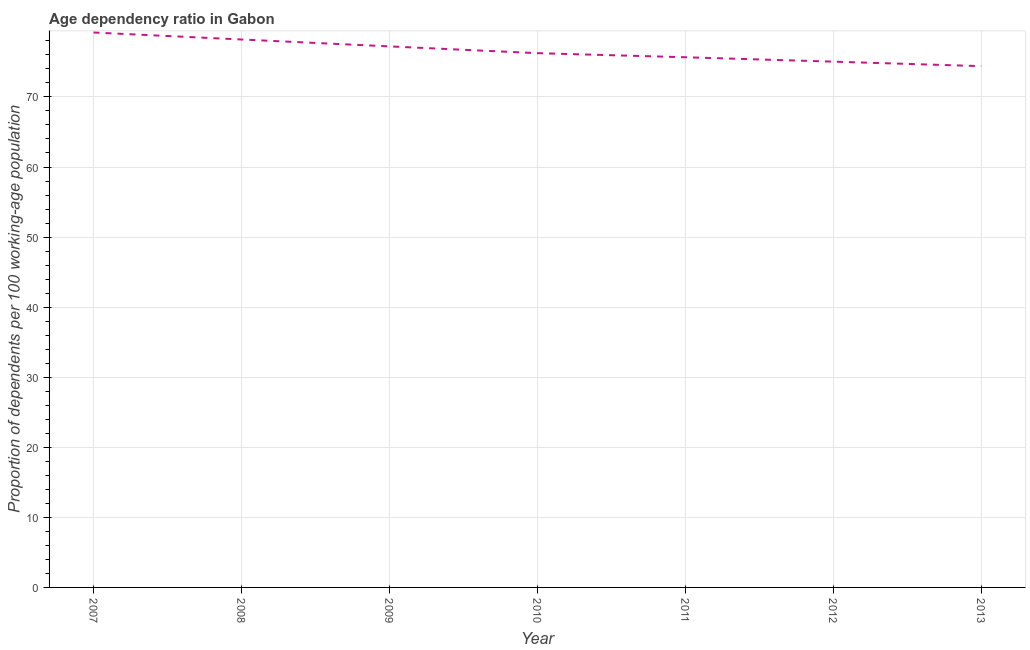What is the age dependency ratio in 2008?
Provide a succinct answer. 78.2. Across all years, what is the maximum age dependency ratio?
Offer a terse response. 79.19. Across all years, what is the minimum age dependency ratio?
Provide a succinct answer. 74.39. What is the sum of the age dependency ratio?
Provide a short and direct response. 535.95. What is the difference between the age dependency ratio in 2008 and 2012?
Make the answer very short. 3.16. What is the average age dependency ratio per year?
Make the answer very short. 76.56. What is the median age dependency ratio?
Provide a short and direct response. 76.25. In how many years, is the age dependency ratio greater than 30 ?
Give a very brief answer. 7. Do a majority of the years between 2013 and 2010 (inclusive) have age dependency ratio greater than 16 ?
Keep it short and to the point. Yes. What is the ratio of the age dependency ratio in 2009 to that in 2012?
Your answer should be compact. 1.03. Is the difference between the age dependency ratio in 2007 and 2008 greater than the difference between any two years?
Ensure brevity in your answer.  No. What is the difference between the highest and the second highest age dependency ratio?
Offer a very short reply. 1. Is the sum of the age dependency ratio in 2007 and 2008 greater than the maximum age dependency ratio across all years?
Provide a succinct answer. Yes. What is the difference between the highest and the lowest age dependency ratio?
Keep it short and to the point. 4.8. Does the age dependency ratio monotonically increase over the years?
Keep it short and to the point. No. How many lines are there?
Provide a short and direct response. 1. What is the difference between two consecutive major ticks on the Y-axis?
Offer a terse response. 10. Does the graph contain grids?
Provide a succinct answer. Yes. What is the title of the graph?
Provide a succinct answer. Age dependency ratio in Gabon. What is the label or title of the Y-axis?
Offer a very short reply. Proportion of dependents per 100 working-age population. What is the Proportion of dependents per 100 working-age population in 2007?
Provide a short and direct response. 79.19. What is the Proportion of dependents per 100 working-age population of 2008?
Offer a terse response. 78.2. What is the Proportion of dependents per 100 working-age population of 2009?
Offer a terse response. 77.21. What is the Proportion of dependents per 100 working-age population in 2010?
Offer a terse response. 76.25. What is the Proportion of dependents per 100 working-age population in 2011?
Ensure brevity in your answer.  75.66. What is the Proportion of dependents per 100 working-age population in 2012?
Provide a succinct answer. 75.04. What is the Proportion of dependents per 100 working-age population of 2013?
Your answer should be compact. 74.39. What is the difference between the Proportion of dependents per 100 working-age population in 2007 and 2008?
Offer a terse response. 1. What is the difference between the Proportion of dependents per 100 working-age population in 2007 and 2009?
Give a very brief answer. 1.98. What is the difference between the Proportion of dependents per 100 working-age population in 2007 and 2010?
Offer a terse response. 2.95. What is the difference between the Proportion of dependents per 100 working-age population in 2007 and 2011?
Your response must be concise. 3.53. What is the difference between the Proportion of dependents per 100 working-age population in 2007 and 2012?
Offer a terse response. 4.16. What is the difference between the Proportion of dependents per 100 working-age population in 2007 and 2013?
Your answer should be very brief. 4.8. What is the difference between the Proportion of dependents per 100 working-age population in 2008 and 2009?
Your response must be concise. 0.98. What is the difference between the Proportion of dependents per 100 working-age population in 2008 and 2010?
Offer a very short reply. 1.95. What is the difference between the Proportion of dependents per 100 working-age population in 2008 and 2011?
Your answer should be compact. 2.53. What is the difference between the Proportion of dependents per 100 working-age population in 2008 and 2012?
Offer a very short reply. 3.16. What is the difference between the Proportion of dependents per 100 working-age population in 2008 and 2013?
Offer a terse response. 3.8. What is the difference between the Proportion of dependents per 100 working-age population in 2009 and 2010?
Offer a terse response. 0.97. What is the difference between the Proportion of dependents per 100 working-age population in 2009 and 2011?
Offer a very short reply. 1.55. What is the difference between the Proportion of dependents per 100 working-age population in 2009 and 2012?
Ensure brevity in your answer.  2.18. What is the difference between the Proportion of dependents per 100 working-age population in 2009 and 2013?
Make the answer very short. 2.82. What is the difference between the Proportion of dependents per 100 working-age population in 2010 and 2011?
Your answer should be compact. 0.58. What is the difference between the Proportion of dependents per 100 working-age population in 2010 and 2012?
Provide a short and direct response. 1.21. What is the difference between the Proportion of dependents per 100 working-age population in 2010 and 2013?
Provide a succinct answer. 1.85. What is the difference between the Proportion of dependents per 100 working-age population in 2011 and 2012?
Your answer should be compact. 0.63. What is the difference between the Proportion of dependents per 100 working-age population in 2011 and 2013?
Provide a succinct answer. 1.27. What is the difference between the Proportion of dependents per 100 working-age population in 2012 and 2013?
Keep it short and to the point. 0.64. What is the ratio of the Proportion of dependents per 100 working-age population in 2007 to that in 2009?
Offer a very short reply. 1.03. What is the ratio of the Proportion of dependents per 100 working-age population in 2007 to that in 2010?
Make the answer very short. 1.04. What is the ratio of the Proportion of dependents per 100 working-age population in 2007 to that in 2011?
Provide a short and direct response. 1.05. What is the ratio of the Proportion of dependents per 100 working-age population in 2007 to that in 2012?
Offer a very short reply. 1.05. What is the ratio of the Proportion of dependents per 100 working-age population in 2007 to that in 2013?
Ensure brevity in your answer.  1.06. What is the ratio of the Proportion of dependents per 100 working-age population in 2008 to that in 2010?
Your response must be concise. 1.03. What is the ratio of the Proportion of dependents per 100 working-age population in 2008 to that in 2011?
Offer a very short reply. 1.03. What is the ratio of the Proportion of dependents per 100 working-age population in 2008 to that in 2012?
Keep it short and to the point. 1.04. What is the ratio of the Proportion of dependents per 100 working-age population in 2008 to that in 2013?
Your answer should be compact. 1.05. What is the ratio of the Proportion of dependents per 100 working-age population in 2009 to that in 2010?
Offer a terse response. 1.01. What is the ratio of the Proportion of dependents per 100 working-age population in 2009 to that in 2013?
Your answer should be very brief. 1.04. What is the ratio of the Proportion of dependents per 100 working-age population in 2010 to that in 2011?
Ensure brevity in your answer.  1.01. What is the ratio of the Proportion of dependents per 100 working-age population in 2010 to that in 2012?
Make the answer very short. 1.02. What is the ratio of the Proportion of dependents per 100 working-age population in 2010 to that in 2013?
Give a very brief answer. 1.02. What is the ratio of the Proportion of dependents per 100 working-age population in 2011 to that in 2012?
Your answer should be very brief. 1.01. What is the ratio of the Proportion of dependents per 100 working-age population in 2011 to that in 2013?
Offer a terse response. 1.02. 